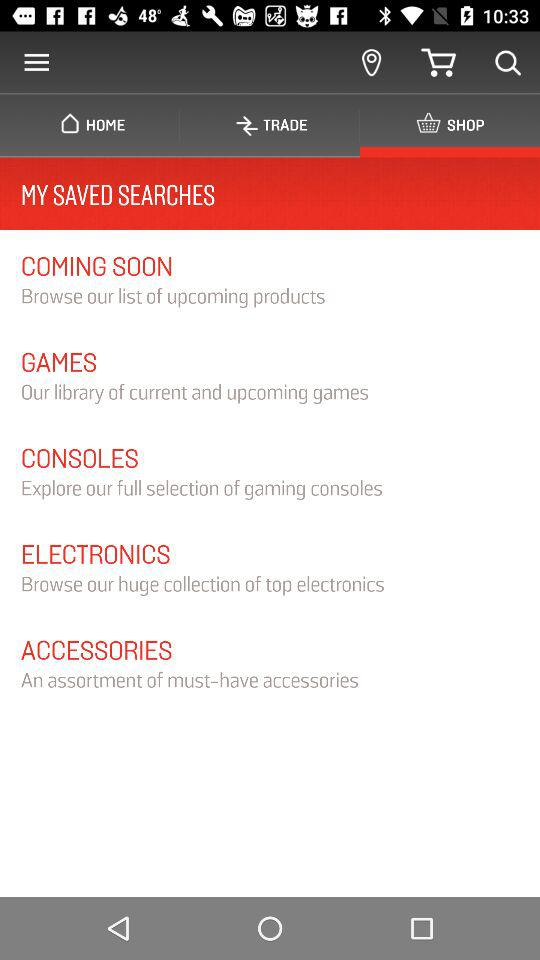Which tab was selected there? The selected tab was "SHOP". 